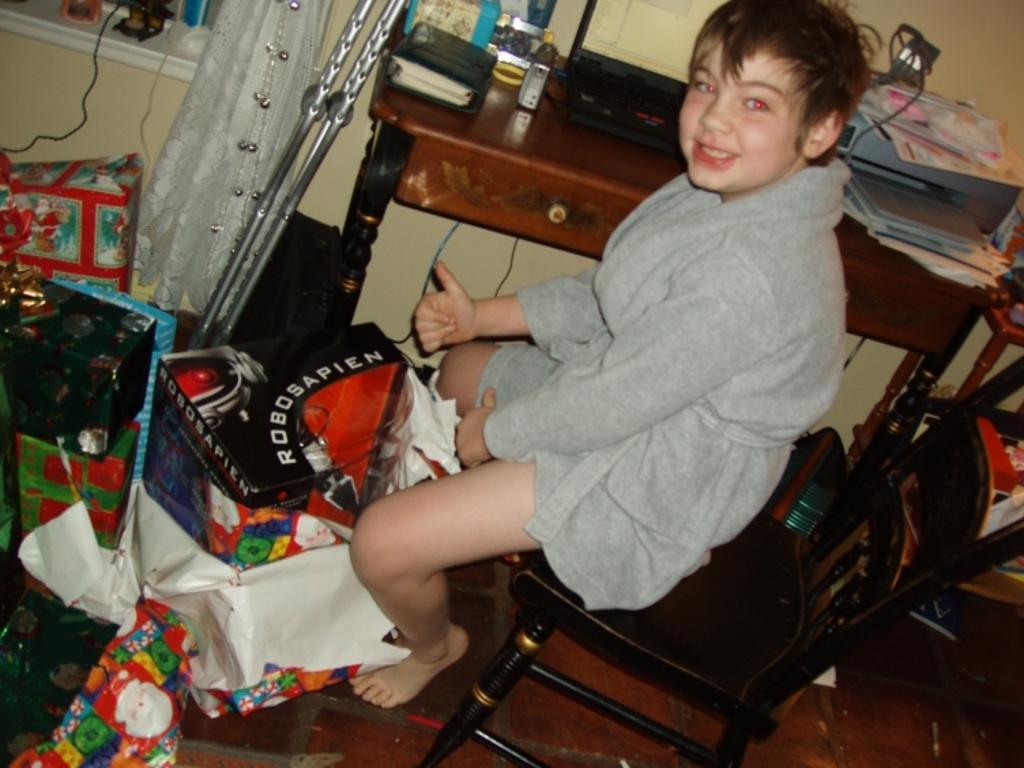Please provide a concise description of this image. In this picture I can see a boy is sitting on the chair in the middle, there is a table beside of him. On the left side I can see few things. 